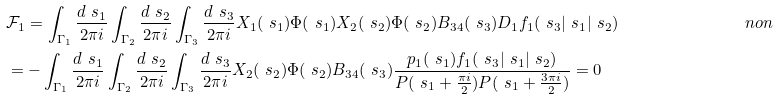<formula> <loc_0><loc_0><loc_500><loc_500>& \mathcal { F } _ { 1 } = \int _ { \Gamma _ { 1 } } \frac { d \ s _ { 1 } } { 2 \pi i } \int _ { \Gamma _ { 2 } } \frac { d \ s _ { 2 } } { 2 \pi i } \int _ { \Gamma _ { 3 } } \frac { d \ s _ { 3 } } { 2 \pi i } X _ { 1 } ( \ s _ { 1 } ) \Phi ( \ s _ { 1 } ) X _ { 2 } ( \ s _ { 2 } ) \Phi ( \ s _ { 2 } ) B _ { 3 4 } ( \ s _ { 3 } ) D _ { 1 } f _ { 1 } ( \ s _ { 3 } | \ s _ { 1 } | \ s _ { 2 } ) & \ n o n \\ & = - \int _ { \Gamma _ { 1 } } \frac { d \ s _ { 1 } } { 2 \pi i } \int _ { \Gamma _ { 2 } } \frac { d \ s _ { 2 } } { 2 \pi i } \int _ { \Gamma _ { 3 } } \frac { d \ s _ { 3 } } { 2 \pi i } X _ { 2 } ( \ s _ { 2 } ) \Phi ( \ s _ { 2 } ) B _ { 3 4 } ( \ s _ { 3 } ) \frac { p _ { 1 } ( \ s _ { 1 } ) f _ { 1 } ( \ s _ { 3 } | \ s _ { 1 } | \ s _ { 2 } ) } { P ( \ s _ { 1 } + \frac { \pi i } { 2 } ) P ( \ s _ { 1 } + \frac { 3 \pi i } { 2 } ) } = 0 &</formula> 